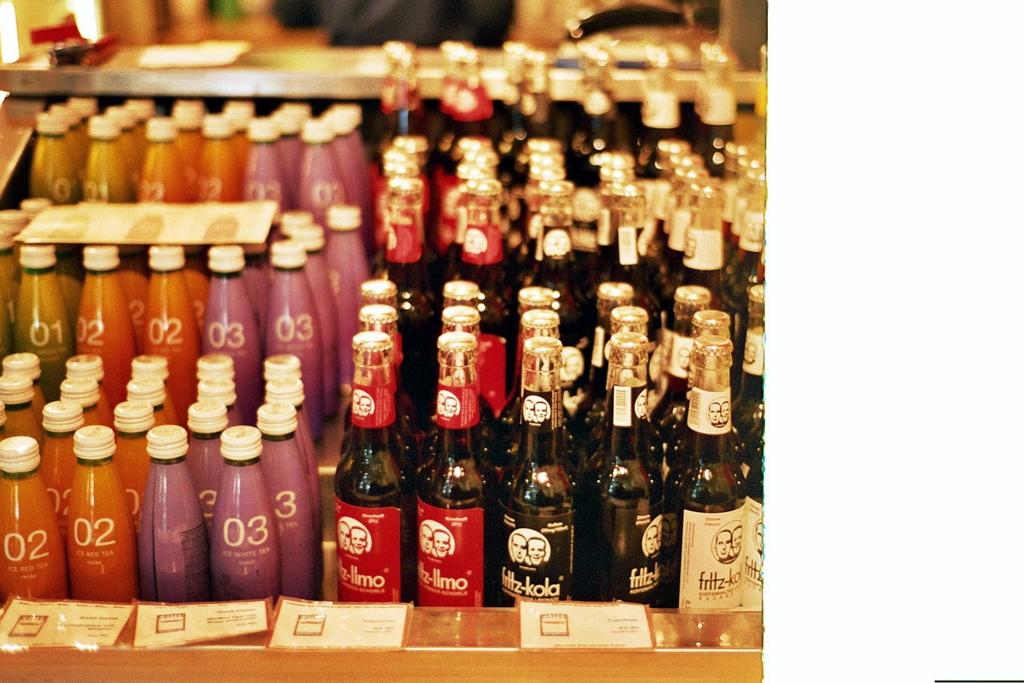What number are the orange bottles on the left?
Ensure brevity in your answer.  02. 